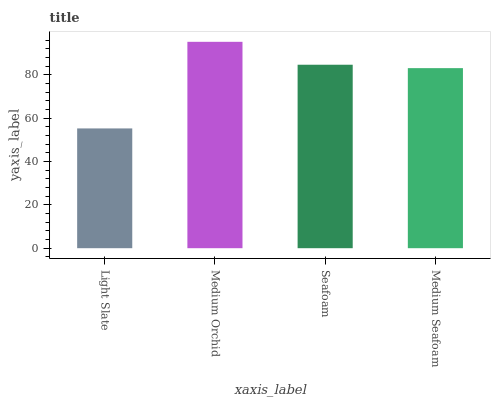Is Seafoam the minimum?
Answer yes or no. No. Is Seafoam the maximum?
Answer yes or no. No. Is Medium Orchid greater than Seafoam?
Answer yes or no. Yes. Is Seafoam less than Medium Orchid?
Answer yes or no. Yes. Is Seafoam greater than Medium Orchid?
Answer yes or no. No. Is Medium Orchid less than Seafoam?
Answer yes or no. No. Is Seafoam the high median?
Answer yes or no. Yes. Is Medium Seafoam the low median?
Answer yes or no. Yes. Is Medium Orchid the high median?
Answer yes or no. No. Is Medium Orchid the low median?
Answer yes or no. No. 